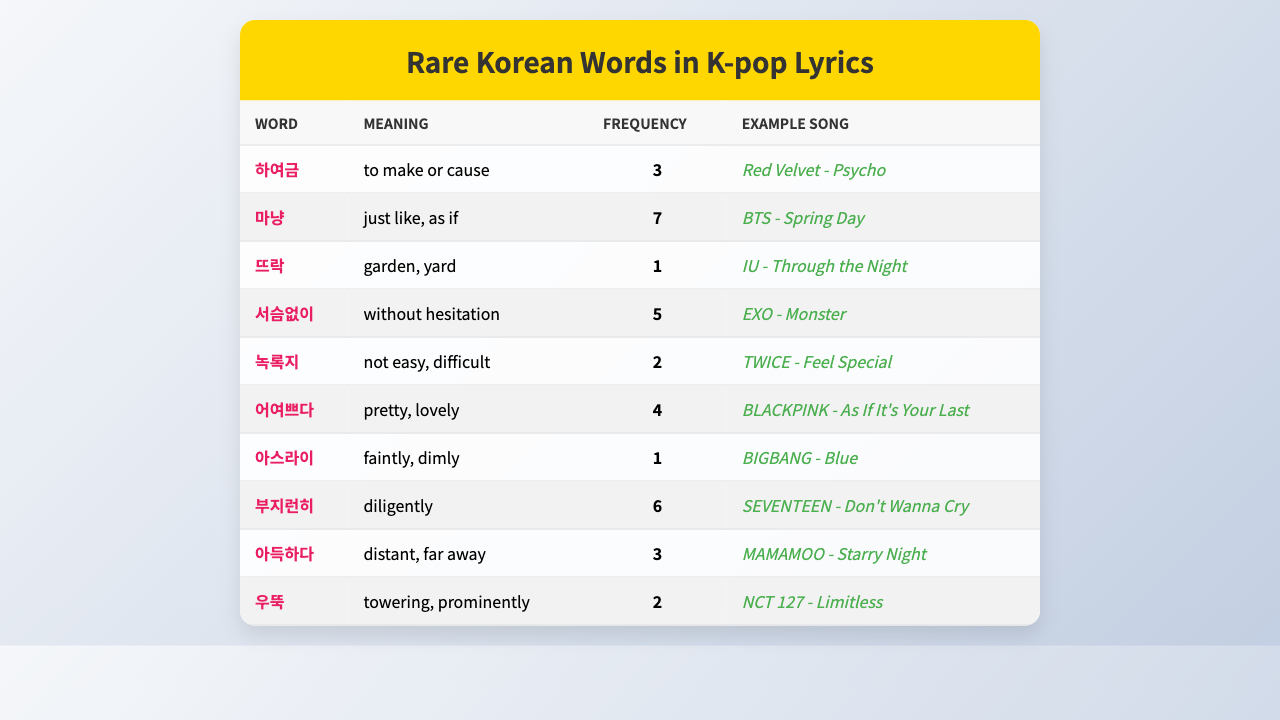What is the frequency of the word "마냥" in K-pop lyrics? The table shows that "마냥" has a frequency of 7 in K-pop lyrics.
Answer: 7 Which word has the highest frequency in the table? By looking at the frequencies, "마냥" has the highest frequency of 7.
Answer: "마냥" How many words have a frequency of more than 4 in K-pop lyrics? The words with a frequency greater than 4 are "마냥" (7), "부지런히" (6), and "서슴없이" (5). Thus, there are 3 words.
Answer: 3 Is the word "어여쁘다" used more frequently than "우뚝"? "어여쁘다" has a frequency of 4 and "우뚝" has a frequency of 2. Therefore, "어여쁘다" is used more frequently.
Answer: Yes What is the total frequency of all the words listed in the table? The total frequency is calculated by summing all the frequencies: 3 + 7 + 1 + 5 + 2 + 4 + 1 + 6 + 3 + 2 = 34.
Answer: 34 What is the average frequency of the words in the table? There are 10 words, and their total frequency is 34. The average frequency is 34 / 10 = 3.4.
Answer: 3.4 Which songs feature the rare words with the highest and lowest frequency? The song "BTS - Spring Day" features the word with the highest frequency (마냥, 7), and "IU - Through the Night" features the word with the lowest frequency (뜨락, 1).
Answer: "BTS - Spring Day"; "IU - Through the Night" Are there any words in the table that appear only once in K-pop lyrics? Yes, "뜨락" and "아스라이" both appear only once in K-pop lyrics.
Answer: Yes How many words in the table have meanings related to beauty or attractiveness? The word "어여쁘다" means pretty, and it is the only word related to beauty or attractiveness in the table.
Answer: 1 Which word's meaning is closest to "difficult"? The word "녹록지" means "not easy, difficult".
Answer: "녹록지" 